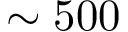<formula> <loc_0><loc_0><loc_500><loc_500>\sim 5 0 0</formula> 